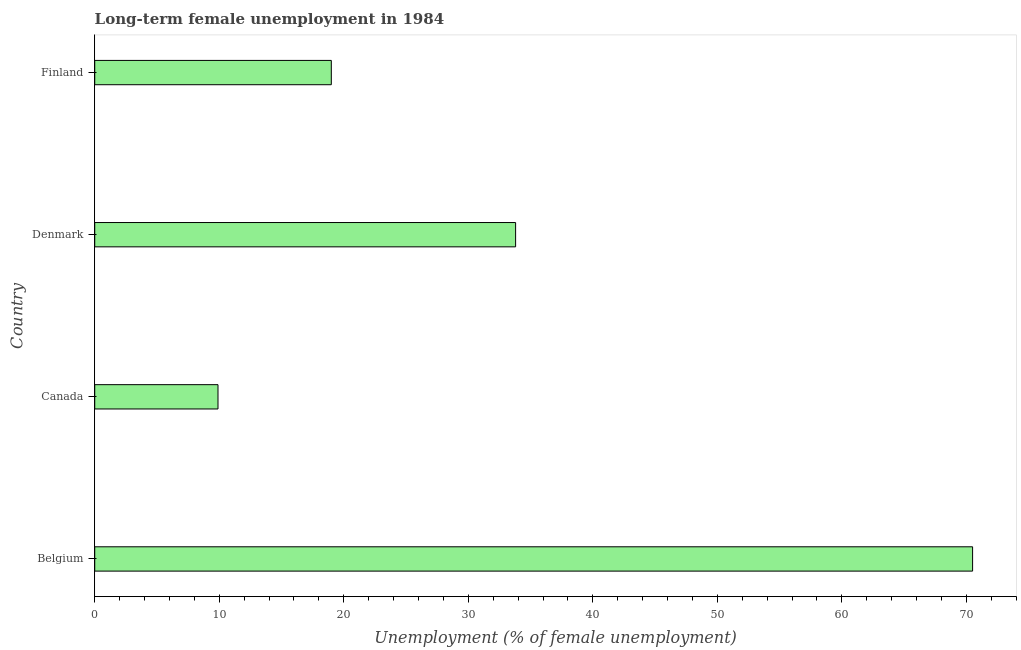What is the title of the graph?
Provide a short and direct response. Long-term female unemployment in 1984. What is the label or title of the X-axis?
Provide a short and direct response. Unemployment (% of female unemployment). What is the label or title of the Y-axis?
Offer a very short reply. Country. Across all countries, what is the maximum long-term female unemployment?
Provide a succinct answer. 70.5. Across all countries, what is the minimum long-term female unemployment?
Make the answer very short. 9.9. In which country was the long-term female unemployment minimum?
Offer a terse response. Canada. What is the sum of the long-term female unemployment?
Your response must be concise. 133.2. What is the difference between the long-term female unemployment in Denmark and Finland?
Offer a terse response. 14.8. What is the average long-term female unemployment per country?
Give a very brief answer. 33.3. What is the median long-term female unemployment?
Give a very brief answer. 26.4. What is the ratio of the long-term female unemployment in Belgium to that in Canada?
Provide a succinct answer. 7.12. Is the difference between the long-term female unemployment in Belgium and Finland greater than the difference between any two countries?
Make the answer very short. No. What is the difference between the highest and the second highest long-term female unemployment?
Give a very brief answer. 36.7. What is the difference between the highest and the lowest long-term female unemployment?
Ensure brevity in your answer.  60.6. Are all the bars in the graph horizontal?
Your answer should be compact. Yes. What is the difference between two consecutive major ticks on the X-axis?
Offer a very short reply. 10. What is the Unemployment (% of female unemployment) in Belgium?
Ensure brevity in your answer.  70.5. What is the Unemployment (% of female unemployment) of Canada?
Make the answer very short. 9.9. What is the Unemployment (% of female unemployment) in Denmark?
Keep it short and to the point. 33.8. What is the Unemployment (% of female unemployment) of Finland?
Your response must be concise. 19. What is the difference between the Unemployment (% of female unemployment) in Belgium and Canada?
Offer a very short reply. 60.6. What is the difference between the Unemployment (% of female unemployment) in Belgium and Denmark?
Your answer should be compact. 36.7. What is the difference between the Unemployment (% of female unemployment) in Belgium and Finland?
Ensure brevity in your answer.  51.5. What is the difference between the Unemployment (% of female unemployment) in Canada and Denmark?
Offer a terse response. -23.9. What is the difference between the Unemployment (% of female unemployment) in Canada and Finland?
Make the answer very short. -9.1. What is the difference between the Unemployment (% of female unemployment) in Denmark and Finland?
Provide a short and direct response. 14.8. What is the ratio of the Unemployment (% of female unemployment) in Belgium to that in Canada?
Offer a terse response. 7.12. What is the ratio of the Unemployment (% of female unemployment) in Belgium to that in Denmark?
Give a very brief answer. 2.09. What is the ratio of the Unemployment (% of female unemployment) in Belgium to that in Finland?
Keep it short and to the point. 3.71. What is the ratio of the Unemployment (% of female unemployment) in Canada to that in Denmark?
Give a very brief answer. 0.29. What is the ratio of the Unemployment (% of female unemployment) in Canada to that in Finland?
Provide a succinct answer. 0.52. What is the ratio of the Unemployment (% of female unemployment) in Denmark to that in Finland?
Give a very brief answer. 1.78. 